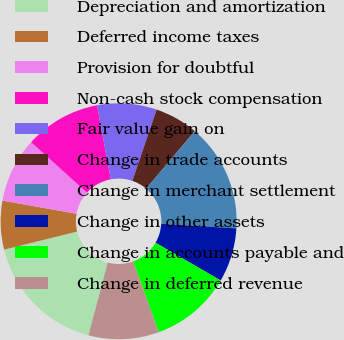Convert chart to OTSL. <chart><loc_0><loc_0><loc_500><loc_500><pie_chart><fcel>Depreciation and amortization<fcel>Deferred income taxes<fcel>Provision for doubtful<fcel>Non-cash stock compensation<fcel>Fair value gain on<fcel>Change in trade accounts<fcel>Change in merchant settlement<fcel>Change in other assets<fcel>Change in accounts payable and<fcel>Change in deferred revenue<nl><fcel>17.02%<fcel>6.67%<fcel>8.89%<fcel>10.37%<fcel>8.15%<fcel>5.93%<fcel>14.8%<fcel>7.41%<fcel>11.11%<fcel>9.63%<nl></chart> 